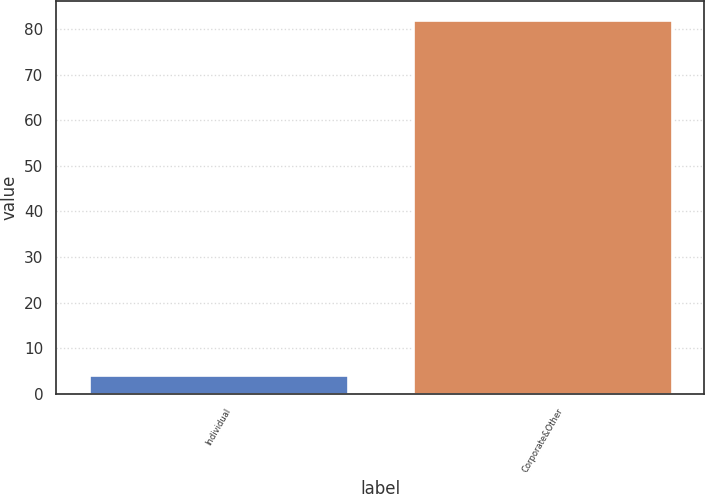<chart> <loc_0><loc_0><loc_500><loc_500><bar_chart><fcel>Individual<fcel>Corporate&Other<nl><fcel>4<fcel>82<nl></chart> 